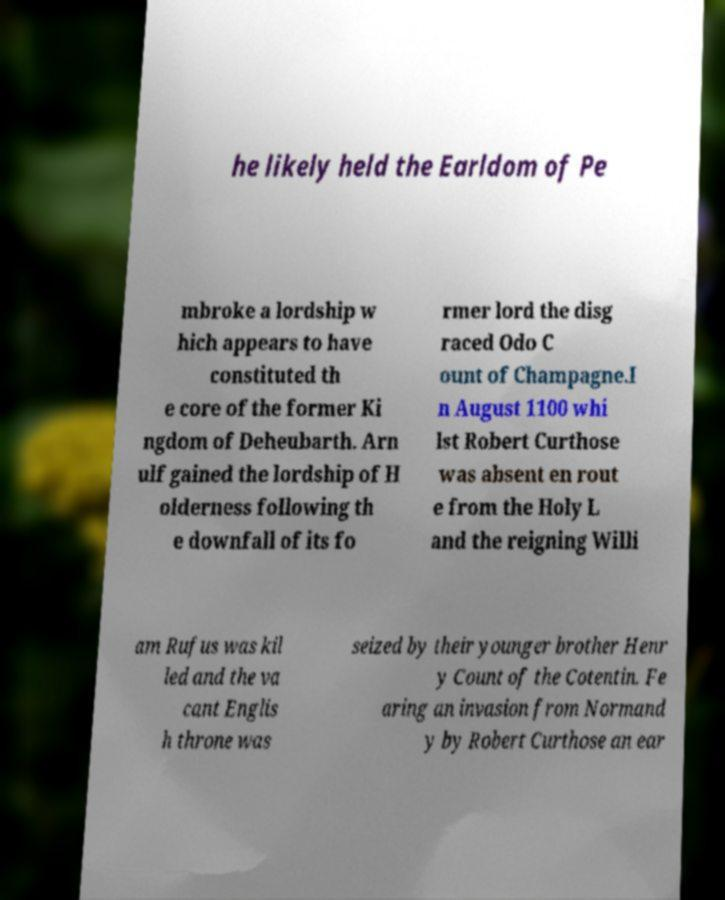Could you assist in decoding the text presented in this image and type it out clearly? he likely held the Earldom of Pe mbroke a lordship w hich appears to have constituted th e core of the former Ki ngdom of Deheubarth. Arn ulf gained the lordship of H olderness following th e downfall of its fo rmer lord the disg raced Odo C ount of Champagne.I n August 1100 whi lst Robert Curthose was absent en rout e from the Holy L and the reigning Willi am Rufus was kil led and the va cant Englis h throne was seized by their younger brother Henr y Count of the Cotentin. Fe aring an invasion from Normand y by Robert Curthose an ear 